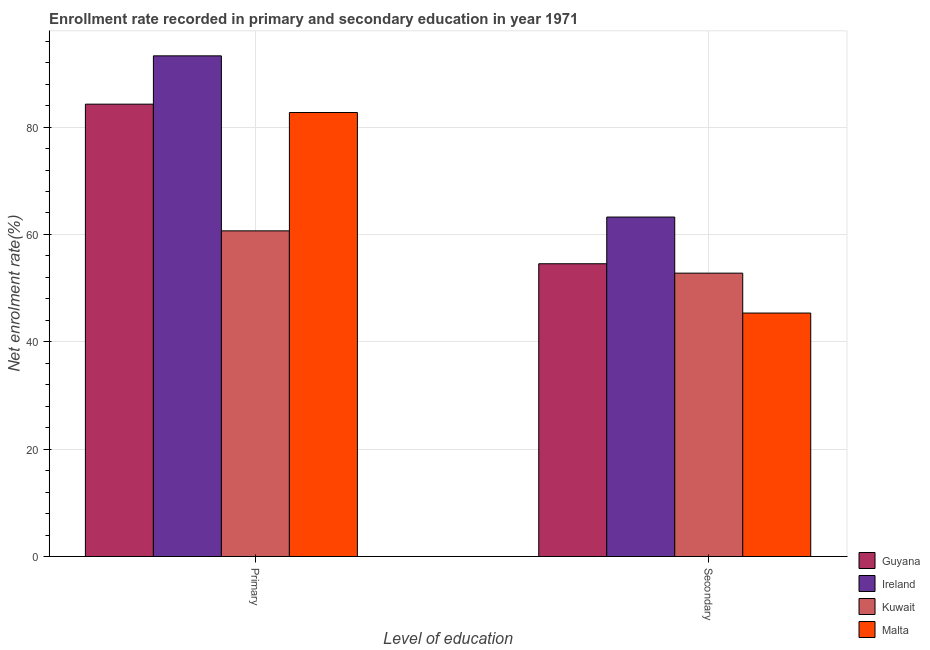How many groups of bars are there?
Your response must be concise. 2. How many bars are there on the 2nd tick from the left?
Ensure brevity in your answer.  4. What is the label of the 2nd group of bars from the left?
Ensure brevity in your answer.  Secondary. What is the enrollment rate in primary education in Guyana?
Provide a short and direct response. 84.27. Across all countries, what is the maximum enrollment rate in secondary education?
Your answer should be compact. 63.24. Across all countries, what is the minimum enrollment rate in secondary education?
Provide a succinct answer. 45.35. In which country was the enrollment rate in primary education maximum?
Offer a terse response. Ireland. In which country was the enrollment rate in primary education minimum?
Ensure brevity in your answer.  Kuwait. What is the total enrollment rate in primary education in the graph?
Your answer should be very brief. 320.91. What is the difference between the enrollment rate in primary education in Guyana and that in Kuwait?
Your answer should be compact. 23.6. What is the difference between the enrollment rate in secondary education in Malta and the enrollment rate in primary education in Guyana?
Provide a succinct answer. -38.91. What is the average enrollment rate in primary education per country?
Ensure brevity in your answer.  80.23. What is the difference between the enrollment rate in secondary education and enrollment rate in primary education in Guyana?
Your answer should be compact. -29.73. What is the ratio of the enrollment rate in secondary education in Kuwait to that in Guyana?
Keep it short and to the point. 0.97. In how many countries, is the enrollment rate in secondary education greater than the average enrollment rate in secondary education taken over all countries?
Provide a short and direct response. 2. What does the 3rd bar from the left in Secondary represents?
Your answer should be compact. Kuwait. What does the 2nd bar from the right in Primary represents?
Keep it short and to the point. Kuwait. How many bars are there?
Keep it short and to the point. 8. Are all the bars in the graph horizontal?
Make the answer very short. No. How many countries are there in the graph?
Keep it short and to the point. 4. Are the values on the major ticks of Y-axis written in scientific E-notation?
Ensure brevity in your answer.  No. Does the graph contain grids?
Give a very brief answer. Yes. Where does the legend appear in the graph?
Give a very brief answer. Bottom right. What is the title of the graph?
Provide a succinct answer. Enrollment rate recorded in primary and secondary education in year 1971. Does "Korea (Republic)" appear as one of the legend labels in the graph?
Keep it short and to the point. No. What is the label or title of the X-axis?
Your response must be concise. Level of education. What is the label or title of the Y-axis?
Your answer should be very brief. Net enrolment rate(%). What is the Net enrolment rate(%) in Guyana in Primary?
Your answer should be compact. 84.27. What is the Net enrolment rate(%) of Ireland in Primary?
Ensure brevity in your answer.  93.27. What is the Net enrolment rate(%) in Kuwait in Primary?
Provide a short and direct response. 60.67. What is the Net enrolment rate(%) in Malta in Primary?
Your answer should be very brief. 82.71. What is the Net enrolment rate(%) in Guyana in Secondary?
Make the answer very short. 54.54. What is the Net enrolment rate(%) in Ireland in Secondary?
Your answer should be very brief. 63.24. What is the Net enrolment rate(%) in Kuwait in Secondary?
Provide a short and direct response. 52.79. What is the Net enrolment rate(%) of Malta in Secondary?
Your answer should be very brief. 45.35. Across all Level of education, what is the maximum Net enrolment rate(%) of Guyana?
Ensure brevity in your answer.  84.27. Across all Level of education, what is the maximum Net enrolment rate(%) of Ireland?
Your answer should be very brief. 93.27. Across all Level of education, what is the maximum Net enrolment rate(%) in Kuwait?
Offer a terse response. 60.67. Across all Level of education, what is the maximum Net enrolment rate(%) in Malta?
Keep it short and to the point. 82.71. Across all Level of education, what is the minimum Net enrolment rate(%) of Guyana?
Provide a short and direct response. 54.54. Across all Level of education, what is the minimum Net enrolment rate(%) in Ireland?
Provide a short and direct response. 63.24. Across all Level of education, what is the minimum Net enrolment rate(%) of Kuwait?
Ensure brevity in your answer.  52.79. Across all Level of education, what is the minimum Net enrolment rate(%) in Malta?
Your answer should be very brief. 45.35. What is the total Net enrolment rate(%) in Guyana in the graph?
Provide a short and direct response. 138.8. What is the total Net enrolment rate(%) in Ireland in the graph?
Provide a succinct answer. 156.5. What is the total Net enrolment rate(%) of Kuwait in the graph?
Ensure brevity in your answer.  113.45. What is the total Net enrolment rate(%) in Malta in the graph?
Your response must be concise. 128.06. What is the difference between the Net enrolment rate(%) of Guyana in Primary and that in Secondary?
Provide a succinct answer. 29.73. What is the difference between the Net enrolment rate(%) of Ireland in Primary and that in Secondary?
Your answer should be very brief. 30.03. What is the difference between the Net enrolment rate(%) of Kuwait in Primary and that in Secondary?
Offer a very short reply. 7.88. What is the difference between the Net enrolment rate(%) in Malta in Primary and that in Secondary?
Your answer should be compact. 37.36. What is the difference between the Net enrolment rate(%) in Guyana in Primary and the Net enrolment rate(%) in Ireland in Secondary?
Provide a succinct answer. 21.03. What is the difference between the Net enrolment rate(%) of Guyana in Primary and the Net enrolment rate(%) of Kuwait in Secondary?
Offer a terse response. 31.48. What is the difference between the Net enrolment rate(%) of Guyana in Primary and the Net enrolment rate(%) of Malta in Secondary?
Make the answer very short. 38.91. What is the difference between the Net enrolment rate(%) in Ireland in Primary and the Net enrolment rate(%) in Kuwait in Secondary?
Give a very brief answer. 40.48. What is the difference between the Net enrolment rate(%) of Ireland in Primary and the Net enrolment rate(%) of Malta in Secondary?
Provide a succinct answer. 47.91. What is the difference between the Net enrolment rate(%) in Kuwait in Primary and the Net enrolment rate(%) in Malta in Secondary?
Provide a short and direct response. 15.31. What is the average Net enrolment rate(%) of Guyana per Level of education?
Offer a very short reply. 69.4. What is the average Net enrolment rate(%) of Ireland per Level of education?
Provide a short and direct response. 78.25. What is the average Net enrolment rate(%) of Kuwait per Level of education?
Offer a terse response. 56.73. What is the average Net enrolment rate(%) in Malta per Level of education?
Your response must be concise. 64.03. What is the difference between the Net enrolment rate(%) of Guyana and Net enrolment rate(%) of Ireland in Primary?
Provide a succinct answer. -9. What is the difference between the Net enrolment rate(%) of Guyana and Net enrolment rate(%) of Kuwait in Primary?
Keep it short and to the point. 23.6. What is the difference between the Net enrolment rate(%) of Guyana and Net enrolment rate(%) of Malta in Primary?
Provide a short and direct response. 1.56. What is the difference between the Net enrolment rate(%) in Ireland and Net enrolment rate(%) in Kuwait in Primary?
Provide a short and direct response. 32.6. What is the difference between the Net enrolment rate(%) of Ireland and Net enrolment rate(%) of Malta in Primary?
Provide a succinct answer. 10.55. What is the difference between the Net enrolment rate(%) of Kuwait and Net enrolment rate(%) of Malta in Primary?
Your response must be concise. -22.04. What is the difference between the Net enrolment rate(%) of Guyana and Net enrolment rate(%) of Ireland in Secondary?
Keep it short and to the point. -8.7. What is the difference between the Net enrolment rate(%) of Guyana and Net enrolment rate(%) of Kuwait in Secondary?
Offer a very short reply. 1.75. What is the difference between the Net enrolment rate(%) of Guyana and Net enrolment rate(%) of Malta in Secondary?
Give a very brief answer. 9.18. What is the difference between the Net enrolment rate(%) in Ireland and Net enrolment rate(%) in Kuwait in Secondary?
Your answer should be very brief. 10.45. What is the difference between the Net enrolment rate(%) of Ireland and Net enrolment rate(%) of Malta in Secondary?
Offer a very short reply. 17.89. What is the difference between the Net enrolment rate(%) in Kuwait and Net enrolment rate(%) in Malta in Secondary?
Make the answer very short. 7.43. What is the ratio of the Net enrolment rate(%) in Guyana in Primary to that in Secondary?
Provide a short and direct response. 1.55. What is the ratio of the Net enrolment rate(%) in Ireland in Primary to that in Secondary?
Offer a terse response. 1.47. What is the ratio of the Net enrolment rate(%) of Kuwait in Primary to that in Secondary?
Offer a very short reply. 1.15. What is the ratio of the Net enrolment rate(%) in Malta in Primary to that in Secondary?
Give a very brief answer. 1.82. What is the difference between the highest and the second highest Net enrolment rate(%) of Guyana?
Provide a succinct answer. 29.73. What is the difference between the highest and the second highest Net enrolment rate(%) of Ireland?
Your answer should be compact. 30.03. What is the difference between the highest and the second highest Net enrolment rate(%) of Kuwait?
Your response must be concise. 7.88. What is the difference between the highest and the second highest Net enrolment rate(%) of Malta?
Your answer should be compact. 37.36. What is the difference between the highest and the lowest Net enrolment rate(%) of Guyana?
Provide a succinct answer. 29.73. What is the difference between the highest and the lowest Net enrolment rate(%) of Ireland?
Give a very brief answer. 30.03. What is the difference between the highest and the lowest Net enrolment rate(%) of Kuwait?
Your answer should be compact. 7.88. What is the difference between the highest and the lowest Net enrolment rate(%) of Malta?
Offer a very short reply. 37.36. 